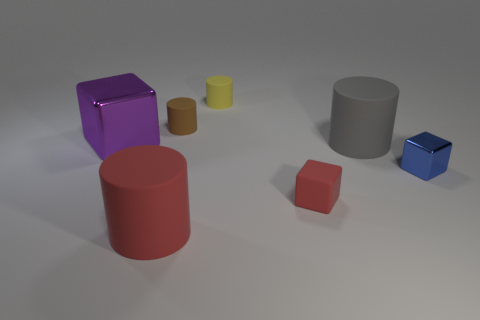Subtract all yellow cylinders. How many cylinders are left? 3 Add 2 brown rubber cylinders. How many objects exist? 9 Subtract all red cubes. How many cubes are left? 2 Subtract all cubes. How many objects are left? 4 Subtract 4 cylinders. How many cylinders are left? 0 Subtract all yellow spheres. How many gray cubes are left? 0 Add 1 small blue rubber cylinders. How many small blue rubber cylinders exist? 1 Subtract 1 gray cylinders. How many objects are left? 6 Subtract all red cubes. Subtract all red balls. How many cubes are left? 2 Subtract all blue metallic objects. Subtract all cyan metal blocks. How many objects are left? 6 